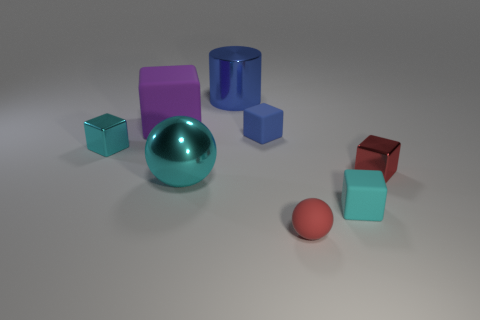Subtract all purple matte blocks. How many blocks are left? 4 Subtract 2 cubes. How many cubes are left? 3 Subtract all gray blocks. Subtract all brown spheres. How many blocks are left? 5 Add 1 large yellow shiny cubes. How many objects exist? 9 Subtract all cylinders. How many objects are left? 7 Add 4 cyan metal cubes. How many cyan metal cubes are left? 5 Add 3 large blue objects. How many large blue objects exist? 4 Subtract 0 gray cubes. How many objects are left? 8 Subtract all matte blocks. Subtract all big metal cylinders. How many objects are left? 4 